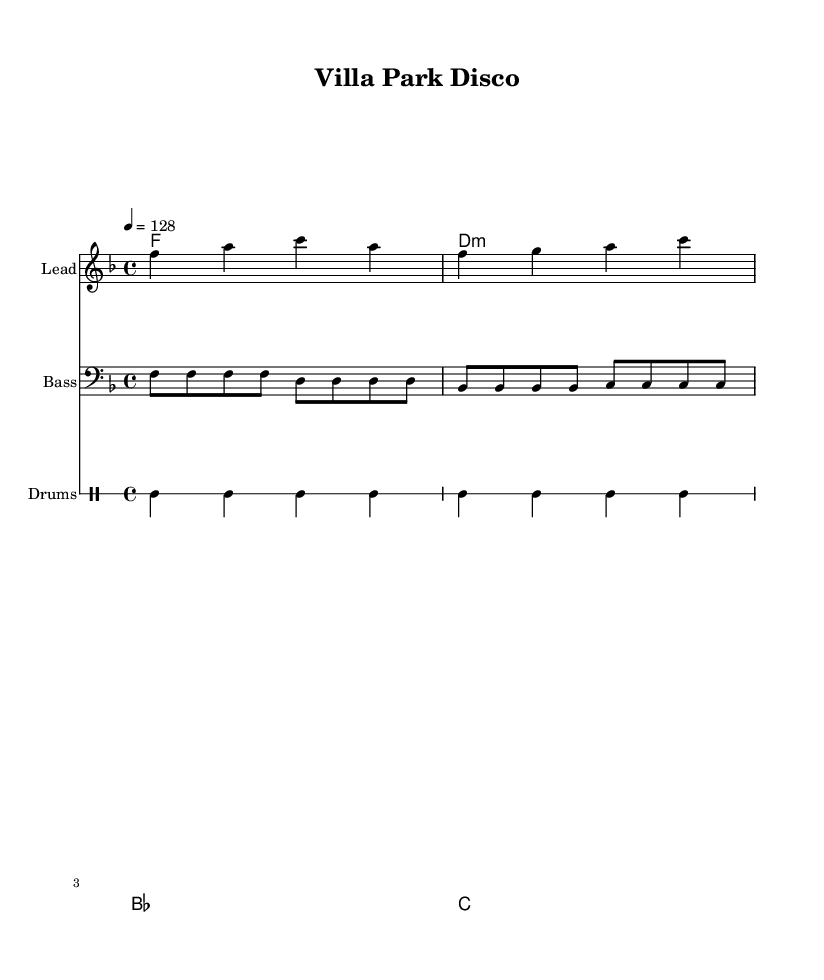What is the key signature of this music? The key signature is F major, which includes one flat (B-flat) indicated at the beginning of the staff.
Answer: F major What is the time signature of the piece? The time signature is 4/4, which is shown at the beginning of the score as a fraction that indicates four beats per measure and the quarter note gets one beat.
Answer: 4/4 What is the tempo marking for this composition? The tempo marking indicates a speed of 128 beats per minute, specified with "4 = 128" at the beginning, meaning that the quarter note is played at this speed.
Answer: 128 How many bars are present in the bass part? By counting the measure lines in the bass part, which is indicated by the use of vertical bar lines, there are a total of four measures in the bass.
Answer: Four What is the first chord in the harmony? The first chord, indicated by the chord names above the staff, is F major, which corresponds to the first measure in the harmony section.
Answer: F What type of drum patterns are used in the piece? The drum patterns include a bass drum and snare drum, evident from the notation in the drum staff showing varied patterns of bass and snare hits.
Answer: Bass and snare What musical style is this piece associated with? This piece is associated with the House genre, marked by its upbeat tempo and syncopated rhythms typical of house music remixes, making it suitable for a dance atmosphere.
Answer: House 